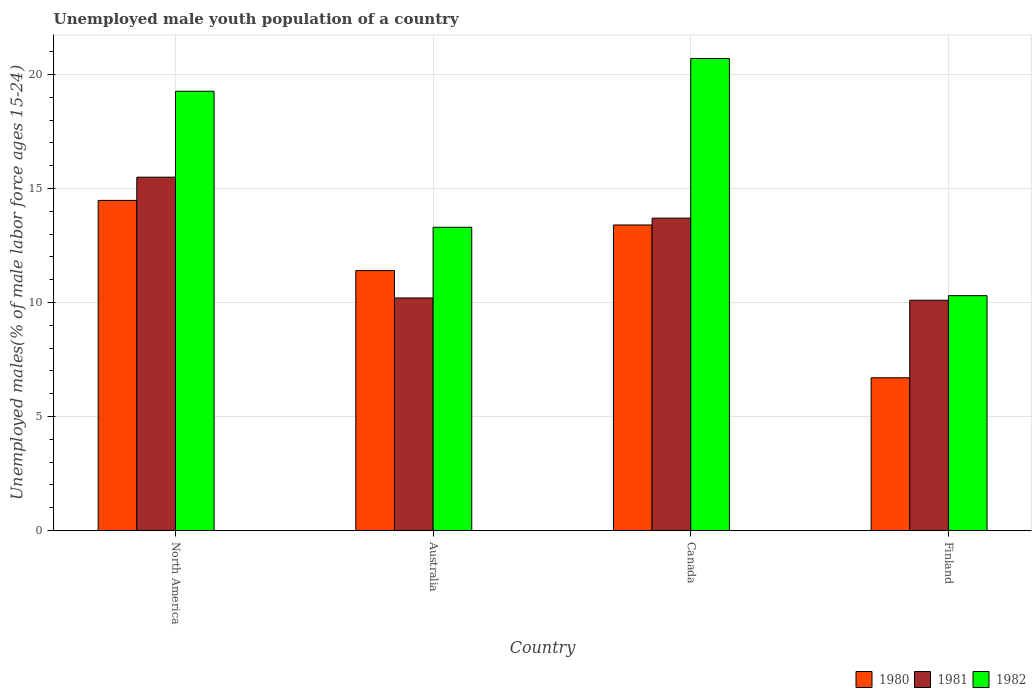How many different coloured bars are there?
Ensure brevity in your answer.  3. How many groups of bars are there?
Make the answer very short. 4. Are the number of bars per tick equal to the number of legend labels?
Your response must be concise. Yes. How many bars are there on the 3rd tick from the right?
Provide a short and direct response. 3. In how many cases, is the number of bars for a given country not equal to the number of legend labels?
Provide a short and direct response. 0. What is the percentage of unemployed male youth population in 1982 in Canada?
Provide a succinct answer. 20.7. Across all countries, what is the maximum percentage of unemployed male youth population in 1980?
Ensure brevity in your answer.  14.48. Across all countries, what is the minimum percentage of unemployed male youth population in 1981?
Make the answer very short. 10.1. In which country was the percentage of unemployed male youth population in 1981 maximum?
Your answer should be very brief. North America. What is the total percentage of unemployed male youth population in 1980 in the graph?
Keep it short and to the point. 45.98. What is the difference between the percentage of unemployed male youth population in 1981 in Australia and that in North America?
Offer a terse response. -5.3. What is the difference between the percentage of unemployed male youth population in 1981 in Canada and the percentage of unemployed male youth population in 1980 in North America?
Offer a terse response. -0.78. What is the average percentage of unemployed male youth population in 1980 per country?
Provide a succinct answer. 11.49. What is the difference between the percentage of unemployed male youth population of/in 1982 and percentage of unemployed male youth population of/in 1980 in Canada?
Ensure brevity in your answer.  7.3. What is the ratio of the percentage of unemployed male youth population in 1982 in Finland to that in North America?
Ensure brevity in your answer.  0.53. What is the difference between the highest and the second highest percentage of unemployed male youth population in 1982?
Your response must be concise. -1.44. What is the difference between the highest and the lowest percentage of unemployed male youth population in 1980?
Your answer should be very brief. 7.78. What does the 1st bar from the left in Australia represents?
Your answer should be compact. 1980. Are all the bars in the graph horizontal?
Your answer should be compact. No. How many countries are there in the graph?
Offer a terse response. 4. Does the graph contain grids?
Keep it short and to the point. Yes. Where does the legend appear in the graph?
Provide a succinct answer. Bottom right. How many legend labels are there?
Your answer should be compact. 3. What is the title of the graph?
Your answer should be compact. Unemployed male youth population of a country. What is the label or title of the X-axis?
Your response must be concise. Country. What is the label or title of the Y-axis?
Your response must be concise. Unemployed males(% of male labor force ages 15-24). What is the Unemployed males(% of male labor force ages 15-24) in 1980 in North America?
Offer a very short reply. 14.48. What is the Unemployed males(% of male labor force ages 15-24) in 1981 in North America?
Your answer should be compact. 15.5. What is the Unemployed males(% of male labor force ages 15-24) of 1982 in North America?
Offer a very short reply. 19.26. What is the Unemployed males(% of male labor force ages 15-24) in 1980 in Australia?
Ensure brevity in your answer.  11.4. What is the Unemployed males(% of male labor force ages 15-24) of 1981 in Australia?
Provide a succinct answer. 10.2. What is the Unemployed males(% of male labor force ages 15-24) in 1982 in Australia?
Your response must be concise. 13.3. What is the Unemployed males(% of male labor force ages 15-24) in 1980 in Canada?
Make the answer very short. 13.4. What is the Unemployed males(% of male labor force ages 15-24) in 1981 in Canada?
Your answer should be very brief. 13.7. What is the Unemployed males(% of male labor force ages 15-24) in 1982 in Canada?
Give a very brief answer. 20.7. What is the Unemployed males(% of male labor force ages 15-24) of 1980 in Finland?
Offer a terse response. 6.7. What is the Unemployed males(% of male labor force ages 15-24) of 1981 in Finland?
Offer a terse response. 10.1. What is the Unemployed males(% of male labor force ages 15-24) of 1982 in Finland?
Give a very brief answer. 10.3. Across all countries, what is the maximum Unemployed males(% of male labor force ages 15-24) of 1980?
Provide a succinct answer. 14.48. Across all countries, what is the maximum Unemployed males(% of male labor force ages 15-24) of 1981?
Give a very brief answer. 15.5. Across all countries, what is the maximum Unemployed males(% of male labor force ages 15-24) of 1982?
Ensure brevity in your answer.  20.7. Across all countries, what is the minimum Unemployed males(% of male labor force ages 15-24) in 1980?
Provide a short and direct response. 6.7. Across all countries, what is the minimum Unemployed males(% of male labor force ages 15-24) of 1981?
Keep it short and to the point. 10.1. Across all countries, what is the minimum Unemployed males(% of male labor force ages 15-24) in 1982?
Keep it short and to the point. 10.3. What is the total Unemployed males(% of male labor force ages 15-24) of 1980 in the graph?
Provide a succinct answer. 45.98. What is the total Unemployed males(% of male labor force ages 15-24) of 1981 in the graph?
Offer a terse response. 49.5. What is the total Unemployed males(% of male labor force ages 15-24) of 1982 in the graph?
Ensure brevity in your answer.  63.56. What is the difference between the Unemployed males(% of male labor force ages 15-24) of 1980 in North America and that in Australia?
Provide a short and direct response. 3.08. What is the difference between the Unemployed males(% of male labor force ages 15-24) in 1981 in North America and that in Australia?
Your answer should be compact. 5.3. What is the difference between the Unemployed males(% of male labor force ages 15-24) in 1982 in North America and that in Australia?
Your response must be concise. 5.96. What is the difference between the Unemployed males(% of male labor force ages 15-24) in 1980 in North America and that in Canada?
Provide a short and direct response. 1.08. What is the difference between the Unemployed males(% of male labor force ages 15-24) in 1981 in North America and that in Canada?
Give a very brief answer. 1.8. What is the difference between the Unemployed males(% of male labor force ages 15-24) in 1982 in North America and that in Canada?
Offer a terse response. -1.44. What is the difference between the Unemployed males(% of male labor force ages 15-24) of 1980 in North America and that in Finland?
Offer a very short reply. 7.78. What is the difference between the Unemployed males(% of male labor force ages 15-24) in 1981 in North America and that in Finland?
Provide a short and direct response. 5.4. What is the difference between the Unemployed males(% of male labor force ages 15-24) of 1982 in North America and that in Finland?
Offer a terse response. 8.96. What is the difference between the Unemployed males(% of male labor force ages 15-24) of 1980 in Australia and that in Canada?
Your answer should be compact. -2. What is the difference between the Unemployed males(% of male labor force ages 15-24) of 1982 in Australia and that in Canada?
Provide a succinct answer. -7.4. What is the difference between the Unemployed males(% of male labor force ages 15-24) in 1980 in Australia and that in Finland?
Offer a terse response. 4.7. What is the difference between the Unemployed males(% of male labor force ages 15-24) of 1981 in Australia and that in Finland?
Your response must be concise. 0.1. What is the difference between the Unemployed males(% of male labor force ages 15-24) of 1982 in Australia and that in Finland?
Offer a terse response. 3. What is the difference between the Unemployed males(% of male labor force ages 15-24) in 1981 in Canada and that in Finland?
Offer a very short reply. 3.6. What is the difference between the Unemployed males(% of male labor force ages 15-24) in 1980 in North America and the Unemployed males(% of male labor force ages 15-24) in 1981 in Australia?
Make the answer very short. 4.28. What is the difference between the Unemployed males(% of male labor force ages 15-24) of 1980 in North America and the Unemployed males(% of male labor force ages 15-24) of 1982 in Australia?
Your response must be concise. 1.18. What is the difference between the Unemployed males(% of male labor force ages 15-24) in 1981 in North America and the Unemployed males(% of male labor force ages 15-24) in 1982 in Australia?
Provide a short and direct response. 2.2. What is the difference between the Unemployed males(% of male labor force ages 15-24) of 1980 in North America and the Unemployed males(% of male labor force ages 15-24) of 1981 in Canada?
Make the answer very short. 0.78. What is the difference between the Unemployed males(% of male labor force ages 15-24) of 1980 in North America and the Unemployed males(% of male labor force ages 15-24) of 1982 in Canada?
Provide a succinct answer. -6.22. What is the difference between the Unemployed males(% of male labor force ages 15-24) in 1981 in North America and the Unemployed males(% of male labor force ages 15-24) in 1982 in Canada?
Offer a terse response. -5.2. What is the difference between the Unemployed males(% of male labor force ages 15-24) of 1980 in North America and the Unemployed males(% of male labor force ages 15-24) of 1981 in Finland?
Make the answer very short. 4.38. What is the difference between the Unemployed males(% of male labor force ages 15-24) of 1980 in North America and the Unemployed males(% of male labor force ages 15-24) of 1982 in Finland?
Provide a succinct answer. 4.18. What is the difference between the Unemployed males(% of male labor force ages 15-24) of 1981 in North America and the Unemployed males(% of male labor force ages 15-24) of 1982 in Finland?
Your answer should be compact. 5.2. What is the difference between the Unemployed males(% of male labor force ages 15-24) of 1980 in Australia and the Unemployed males(% of male labor force ages 15-24) of 1982 in Canada?
Provide a short and direct response. -9.3. What is the difference between the Unemployed males(% of male labor force ages 15-24) in 1981 in Australia and the Unemployed males(% of male labor force ages 15-24) in 1982 in Canada?
Keep it short and to the point. -10.5. What is the difference between the Unemployed males(% of male labor force ages 15-24) of 1980 in Australia and the Unemployed males(% of male labor force ages 15-24) of 1981 in Finland?
Make the answer very short. 1.3. What is the difference between the Unemployed males(% of male labor force ages 15-24) in 1980 in Australia and the Unemployed males(% of male labor force ages 15-24) in 1982 in Finland?
Offer a terse response. 1.1. What is the difference between the Unemployed males(% of male labor force ages 15-24) of 1980 in Canada and the Unemployed males(% of male labor force ages 15-24) of 1981 in Finland?
Make the answer very short. 3.3. What is the average Unemployed males(% of male labor force ages 15-24) of 1980 per country?
Provide a short and direct response. 11.49. What is the average Unemployed males(% of male labor force ages 15-24) in 1981 per country?
Your response must be concise. 12.37. What is the average Unemployed males(% of male labor force ages 15-24) in 1982 per country?
Provide a succinct answer. 15.89. What is the difference between the Unemployed males(% of male labor force ages 15-24) in 1980 and Unemployed males(% of male labor force ages 15-24) in 1981 in North America?
Provide a succinct answer. -1.02. What is the difference between the Unemployed males(% of male labor force ages 15-24) of 1980 and Unemployed males(% of male labor force ages 15-24) of 1982 in North America?
Offer a very short reply. -4.79. What is the difference between the Unemployed males(% of male labor force ages 15-24) of 1981 and Unemployed males(% of male labor force ages 15-24) of 1982 in North America?
Provide a succinct answer. -3.77. What is the difference between the Unemployed males(% of male labor force ages 15-24) in 1980 and Unemployed males(% of male labor force ages 15-24) in 1981 in Australia?
Ensure brevity in your answer.  1.2. What is the difference between the Unemployed males(% of male labor force ages 15-24) of 1981 and Unemployed males(% of male labor force ages 15-24) of 1982 in Australia?
Your response must be concise. -3.1. What is the difference between the Unemployed males(% of male labor force ages 15-24) of 1980 and Unemployed males(% of male labor force ages 15-24) of 1981 in Canada?
Provide a succinct answer. -0.3. What is the difference between the Unemployed males(% of male labor force ages 15-24) in 1980 and Unemployed males(% of male labor force ages 15-24) in 1982 in Canada?
Your response must be concise. -7.3. What is the difference between the Unemployed males(% of male labor force ages 15-24) of 1980 and Unemployed males(% of male labor force ages 15-24) of 1981 in Finland?
Offer a very short reply. -3.4. What is the difference between the Unemployed males(% of male labor force ages 15-24) of 1981 and Unemployed males(% of male labor force ages 15-24) of 1982 in Finland?
Ensure brevity in your answer.  -0.2. What is the ratio of the Unemployed males(% of male labor force ages 15-24) of 1980 in North America to that in Australia?
Your answer should be very brief. 1.27. What is the ratio of the Unemployed males(% of male labor force ages 15-24) in 1981 in North America to that in Australia?
Ensure brevity in your answer.  1.52. What is the ratio of the Unemployed males(% of male labor force ages 15-24) in 1982 in North America to that in Australia?
Offer a terse response. 1.45. What is the ratio of the Unemployed males(% of male labor force ages 15-24) in 1980 in North America to that in Canada?
Provide a succinct answer. 1.08. What is the ratio of the Unemployed males(% of male labor force ages 15-24) of 1981 in North America to that in Canada?
Provide a succinct answer. 1.13. What is the ratio of the Unemployed males(% of male labor force ages 15-24) in 1982 in North America to that in Canada?
Keep it short and to the point. 0.93. What is the ratio of the Unemployed males(% of male labor force ages 15-24) of 1980 in North America to that in Finland?
Your answer should be very brief. 2.16. What is the ratio of the Unemployed males(% of male labor force ages 15-24) of 1981 in North America to that in Finland?
Keep it short and to the point. 1.53. What is the ratio of the Unemployed males(% of male labor force ages 15-24) in 1982 in North America to that in Finland?
Make the answer very short. 1.87. What is the ratio of the Unemployed males(% of male labor force ages 15-24) of 1980 in Australia to that in Canada?
Make the answer very short. 0.85. What is the ratio of the Unemployed males(% of male labor force ages 15-24) of 1981 in Australia to that in Canada?
Offer a very short reply. 0.74. What is the ratio of the Unemployed males(% of male labor force ages 15-24) in 1982 in Australia to that in Canada?
Provide a succinct answer. 0.64. What is the ratio of the Unemployed males(% of male labor force ages 15-24) of 1980 in Australia to that in Finland?
Make the answer very short. 1.7. What is the ratio of the Unemployed males(% of male labor force ages 15-24) in 1981 in Australia to that in Finland?
Offer a very short reply. 1.01. What is the ratio of the Unemployed males(% of male labor force ages 15-24) of 1982 in Australia to that in Finland?
Your answer should be compact. 1.29. What is the ratio of the Unemployed males(% of male labor force ages 15-24) in 1981 in Canada to that in Finland?
Ensure brevity in your answer.  1.36. What is the ratio of the Unemployed males(% of male labor force ages 15-24) in 1982 in Canada to that in Finland?
Provide a short and direct response. 2.01. What is the difference between the highest and the second highest Unemployed males(% of male labor force ages 15-24) in 1980?
Your response must be concise. 1.08. What is the difference between the highest and the second highest Unemployed males(% of male labor force ages 15-24) in 1981?
Offer a very short reply. 1.8. What is the difference between the highest and the second highest Unemployed males(% of male labor force ages 15-24) of 1982?
Make the answer very short. 1.44. What is the difference between the highest and the lowest Unemployed males(% of male labor force ages 15-24) of 1980?
Your answer should be very brief. 7.78. What is the difference between the highest and the lowest Unemployed males(% of male labor force ages 15-24) of 1981?
Make the answer very short. 5.4. 